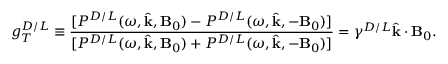Convert formula to latex. <formula><loc_0><loc_0><loc_500><loc_500>g _ { T } ^ { D / L } \equiv \frac { [ P ^ { D / L } ( \omega , \widehat { k } , B _ { 0 } ) - P ^ { D / L } ( \omega , \widehat { k } , - B _ { 0 } ) ] } { [ P ^ { D / L } ( \omega , \widehat { k } , B _ { 0 } ) + P ^ { D / L } ( \omega , \widehat { k } , - B _ { 0 } ) ] } = \gamma ^ { D / L } \hat { k } \cdot B _ { 0 } .</formula> 